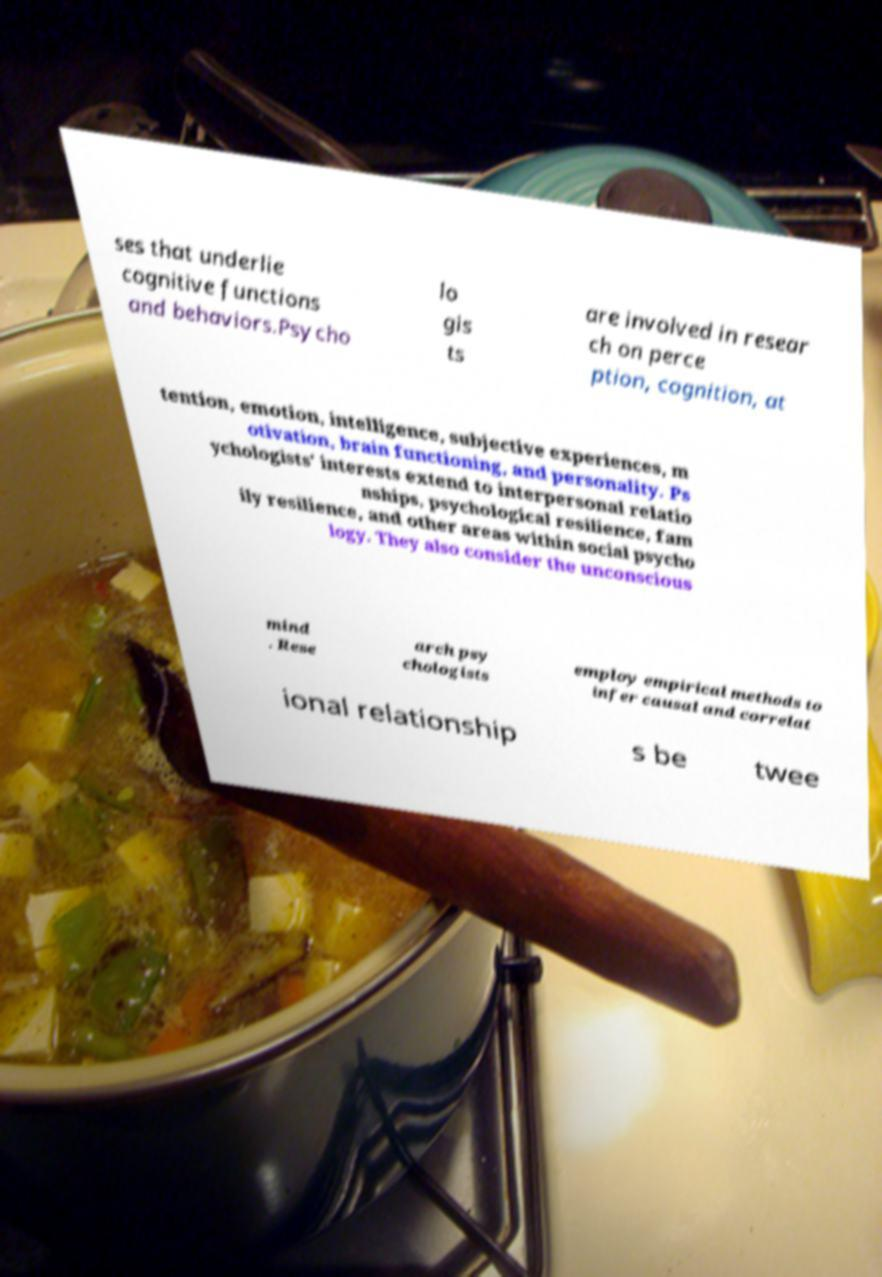Could you extract and type out the text from this image? ses that underlie cognitive functions and behaviors.Psycho lo gis ts are involved in resear ch on perce ption, cognition, at tention, emotion, intelligence, subjective experiences, m otivation, brain functioning, and personality. Ps ychologists' interests extend to interpersonal relatio nships, psychological resilience, fam ily resilience, and other areas within social psycho logy. They also consider the unconscious mind . Rese arch psy chologists employ empirical methods to infer causal and correlat ional relationship s be twee 